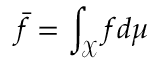Convert formula to latex. <formula><loc_0><loc_0><loc_500><loc_500>\bar { f } = \int _ { \mathcal { X } } f d \mu</formula> 